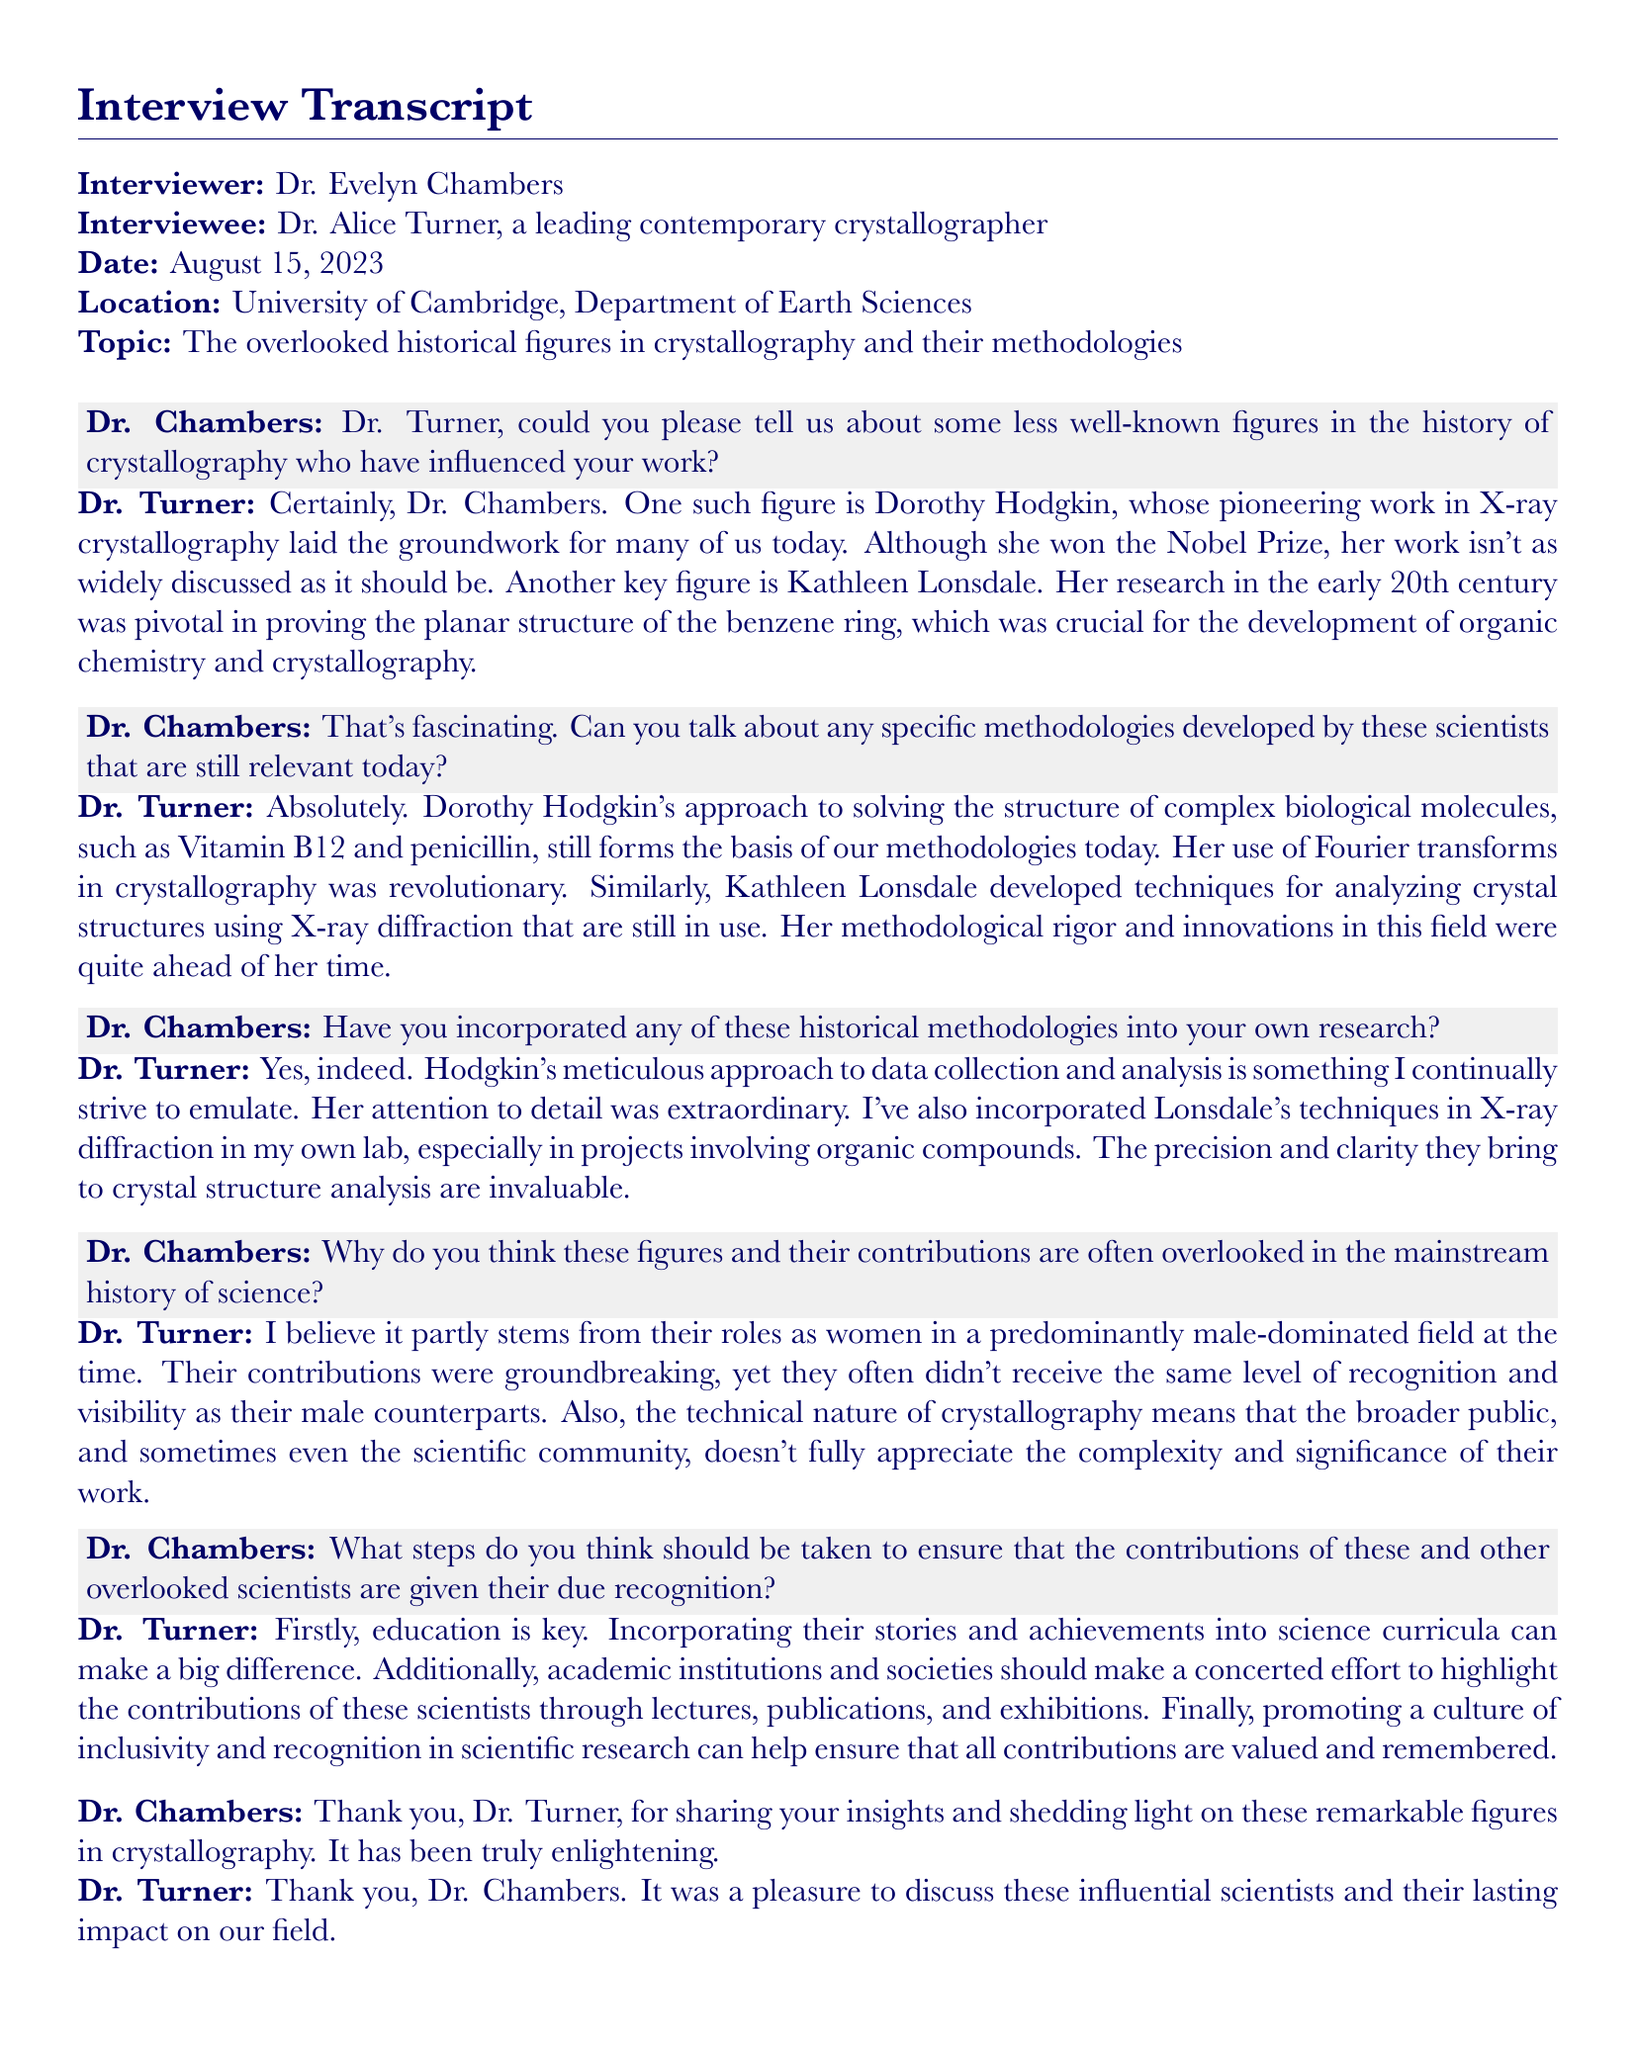What is the name of the interviewee? The name of the interviewee is mentioned in the document as Dr. Alice Turner, a leading contemporary crystallographer.
Answer: Dr. Alice Turner What date was the interview conducted? The document specifies that the interview was conducted on August 15, 2023.
Answer: August 15, 2023 Who is one of the key figures mentioned that influenced Dr. Turner's work? Dr. Turner mentions Dorothy Hodgkin as a significant influence in the field of crystallography.
Answer: Dorothy Hodgkin What methodology did Dorothy Hodgkin develop that is still relevant today? The document states that her use of Fourier transforms in crystallography was revolutionary and is still relevant.
Answer: Fourier transforms Which figure proved the planar structure of the benzene ring? The document attributes this achievement to Kathleen Lonsdale, who conducted pivotal research in the early 20th century.
Answer: Kathleen Lonsdale What is one reason Dr. Turner gives for the overlooked contributions of certain scientists? Dr. Turner suggests that the male-dominated field led to reduced visibility for women scientists’ contributions.
Answer: Male-dominated field What recommendation does Dr. Turner make for recognizing overlooked scientists? Dr. Turner emphasizes the importance of incorporating their stories and achievements into science curricula.
Answer: Incorporating stories in curricula What is the location of the interview? The interview takes place at the University of Cambridge, Department of Earth Sciences.
Answer: University of Cambridge, Department of Earth Sciences 